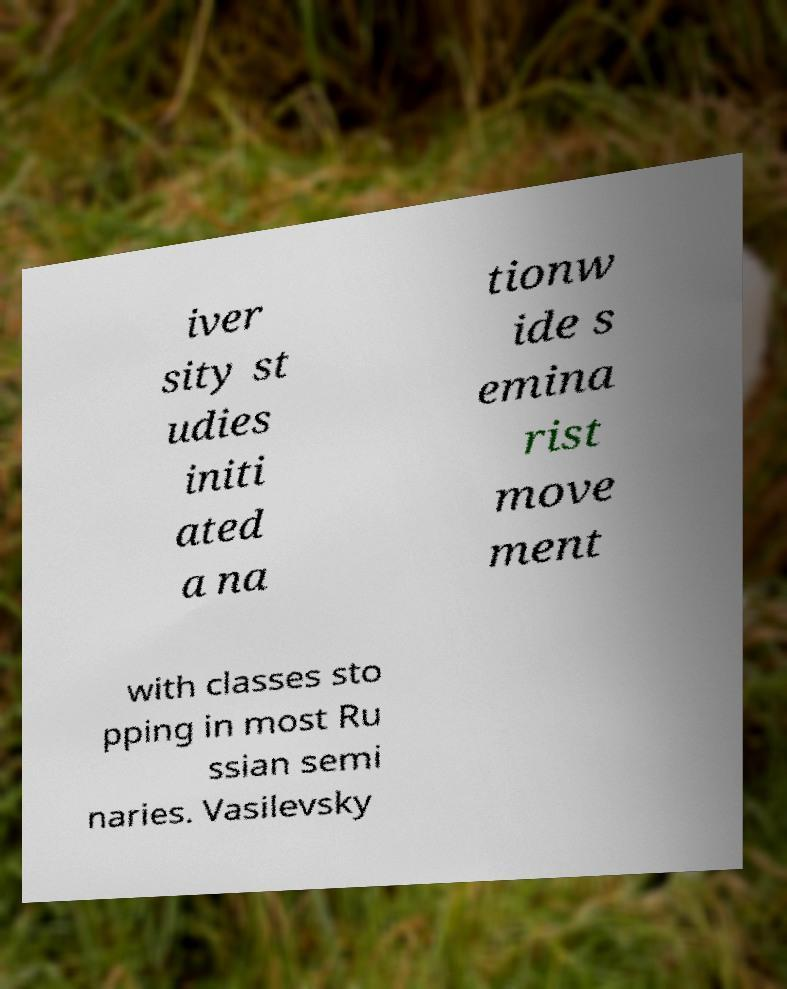Can you accurately transcribe the text from the provided image for me? iver sity st udies initi ated a na tionw ide s emina rist move ment with classes sto pping in most Ru ssian semi naries. Vasilevsky 